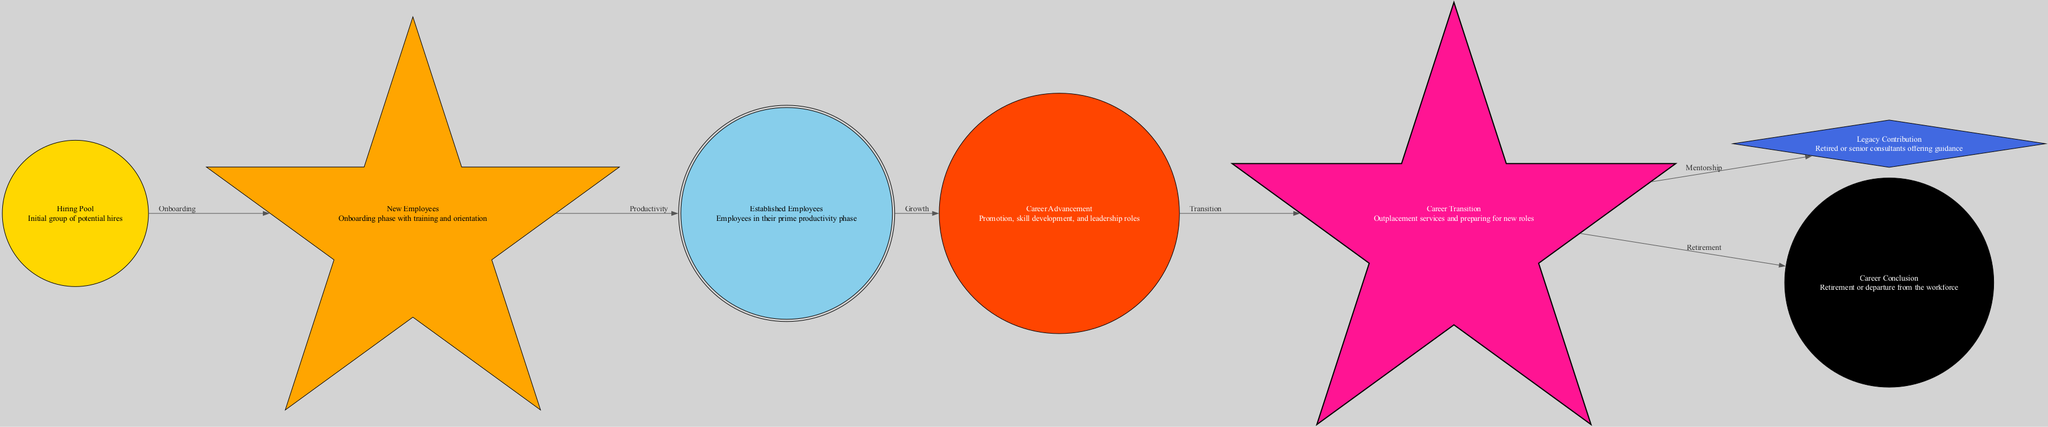What is the first stage of the career path in the diagram? The first stage, represented by the nebula, is labeled as "Hiring Pool," which indicates the initial group of potential hires.
Answer: Hiring Pool How many nodes are present in the diagram? By counting the nodes listed—Nebula, Protostar, MainSequence, RedGiant, Supernova, NeutronStar, and BlackHole—there are a total of seven nodes.
Answer: 7 What is the relationship between "New Employees" and "Established Employees"? The edge labeled "Productivity" connects the "New Employees" node (Protostar) to the "Established Employees" node (MainSequence), indicating a direct relationship of development over time.
Answer: Productivity What phase follows "Career Advancement"? Following the "Career Advancement" node (RedGiant), the next phase indicated by the edge labeled "Transition" leads to the "Career Transition" node (Supernova).
Answer: Career Transition What type of node is "Legacy Contribution"? The node labeled "Legacy Contribution" (NeutronStar) is shaped as a diamond, which differentiates it from other nodes in the diagram.
Answer: Diamond Which two nodes are connected by the edge labeled "Mentorship"? The edge labeled "Mentorship" connects the "Career Transition" node (Supernova) to the "Legacy Contribution" node (NeutronStar), indicating guidance provided during the transition phase.
Answer: Career Transition and Legacy Contribution What color represents the "Established Employees" node? The node representing "Established Employees" (MainSequence) is filled with a light blue color, specifically #87CEEB.
Answer: #87CEEB Which node signifies the end of a career? The "Career Conclusion" node, represented by the BlackHole, signifies the end of a career in this diagram.
Answer: Career Conclusion 